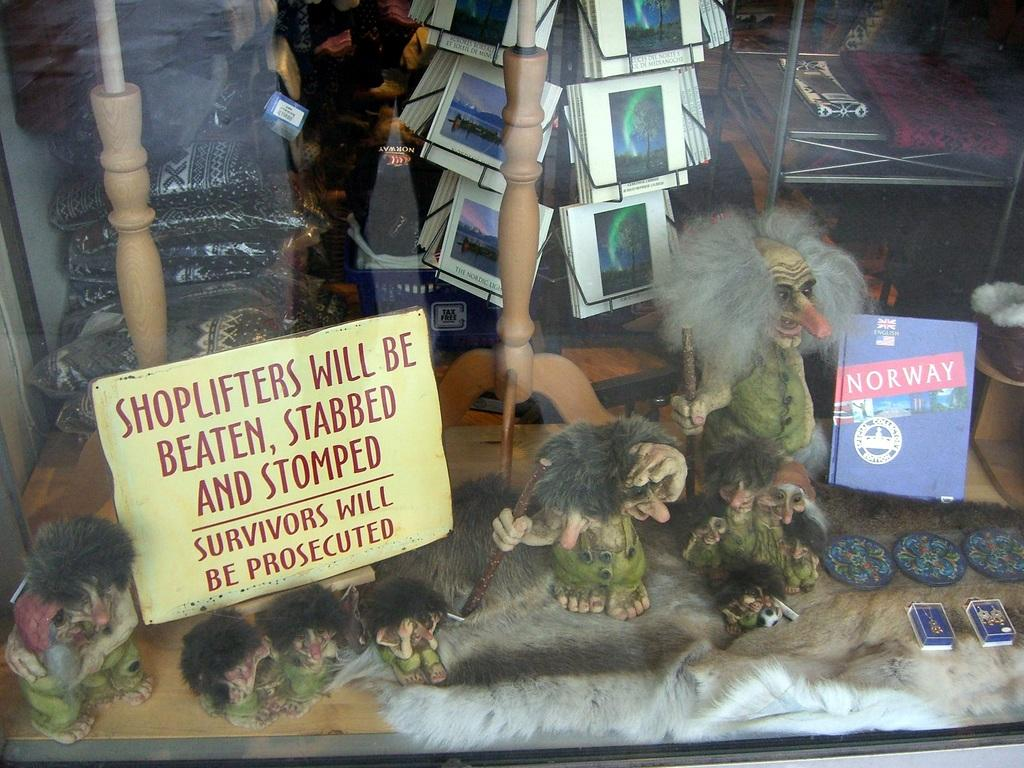<image>
Render a clear and concise summary of the photo. A display full of souvenirs warns shoplifters that they will be stabbed, beaten, and stomped. 